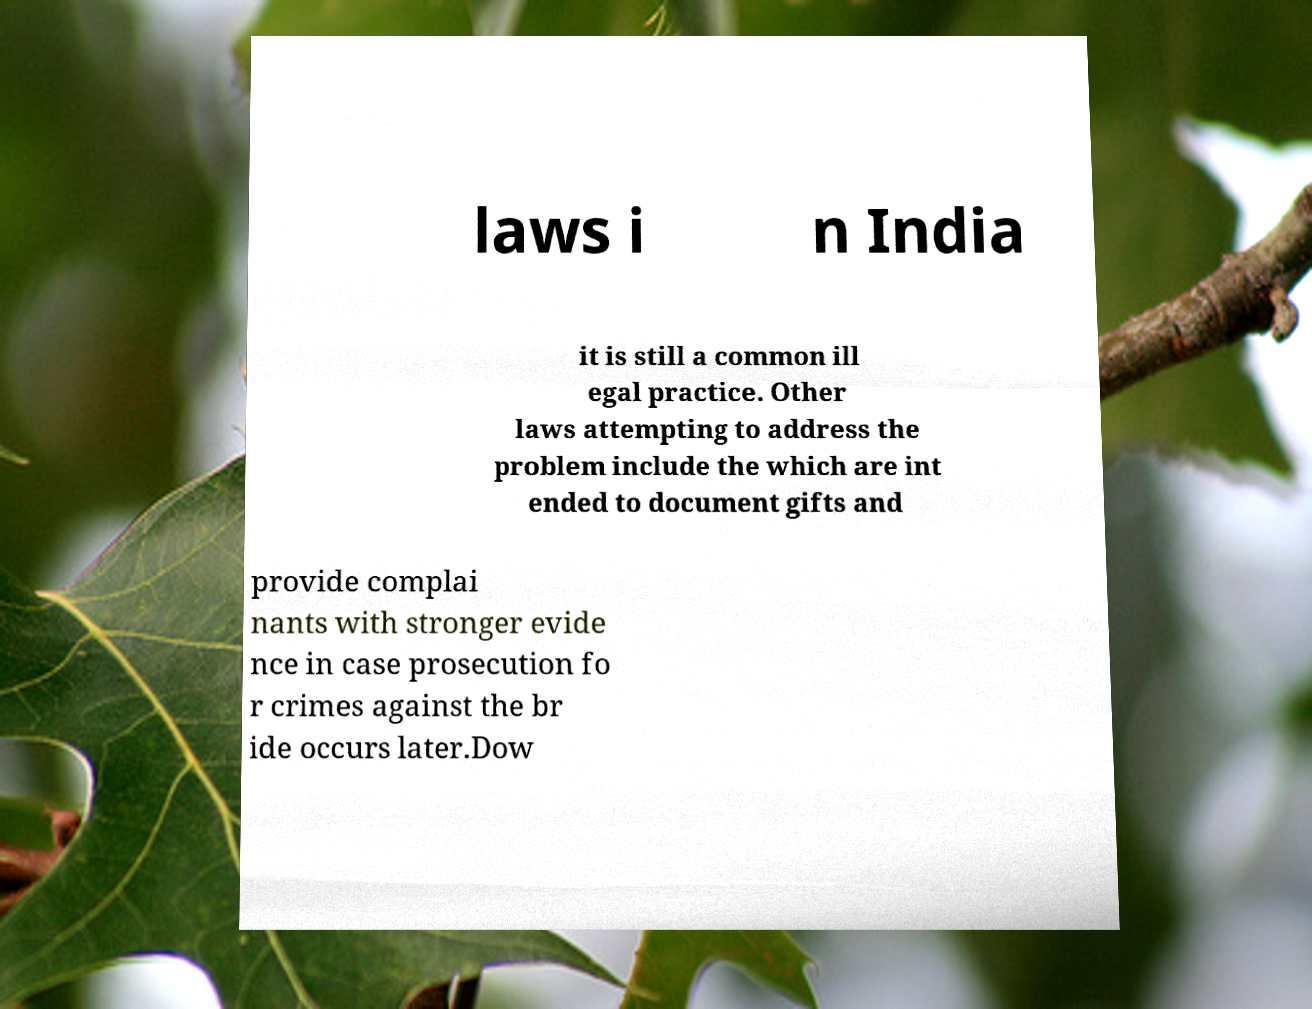Can you read and provide the text displayed in the image?This photo seems to have some interesting text. Can you extract and type it out for me? laws i n India it is still a common ill egal practice. Other laws attempting to address the problem include the which are int ended to document gifts and provide complai nants with stronger evide nce in case prosecution fo r crimes against the br ide occurs later.Dow 